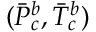Convert formula to latex. <formula><loc_0><loc_0><loc_500><loc_500>( \ B a r { P } _ { c } ^ { b } , \ B a r { T } _ { c } ^ { b } )</formula> 